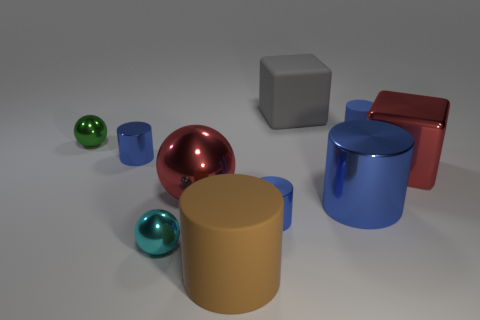How many blue cylinders must be subtracted to get 2 blue cylinders? 2 Subtract all yellow cubes. How many blue cylinders are left? 4 Subtract all brown cylinders. How many cylinders are left? 4 Subtract all small rubber cylinders. How many cylinders are left? 4 Subtract 2 cylinders. How many cylinders are left? 3 Subtract all cyan cylinders. Subtract all purple spheres. How many cylinders are left? 5 Subtract all tiny blue shiny cylinders. Subtract all big blue shiny cylinders. How many objects are left? 7 Add 6 big matte cylinders. How many big matte cylinders are left? 7 Add 4 small blue objects. How many small blue objects exist? 7 Subtract 1 green balls. How many objects are left? 9 